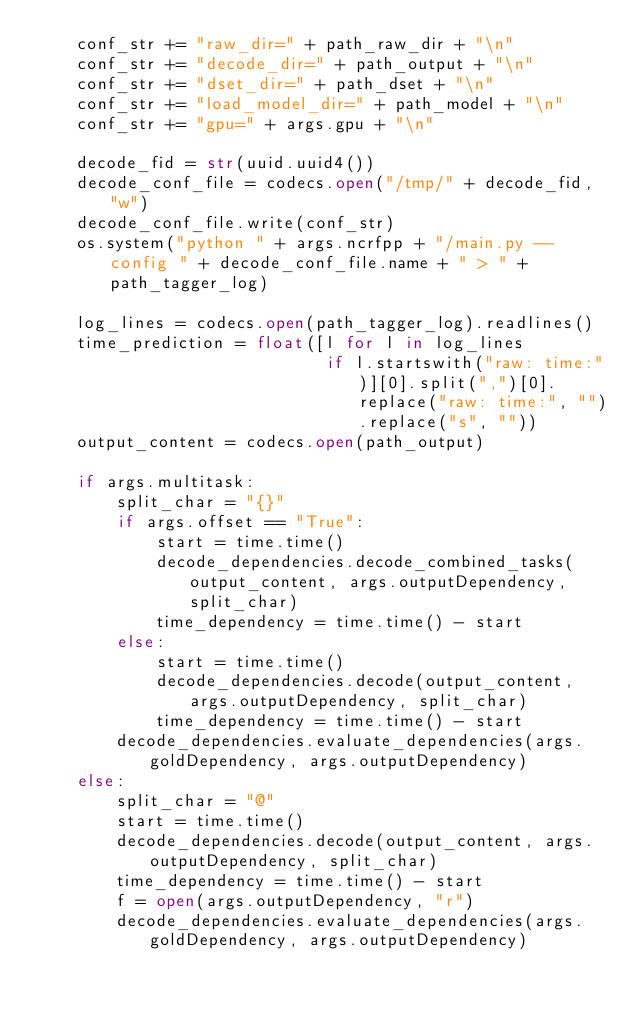Convert code to text. <code><loc_0><loc_0><loc_500><loc_500><_Python_>    conf_str += "raw_dir=" + path_raw_dir + "\n"
    conf_str += "decode_dir=" + path_output + "\n"
    conf_str += "dset_dir=" + path_dset + "\n"
    conf_str += "load_model_dir=" + path_model + "\n"
    conf_str += "gpu=" + args.gpu + "\n"

    decode_fid = str(uuid.uuid4())
    decode_conf_file = codecs.open("/tmp/" + decode_fid, "w")
    decode_conf_file.write(conf_str)
    os.system("python " + args.ncrfpp + "/main.py --config " + decode_conf_file.name + " > " + path_tagger_log)

    log_lines = codecs.open(path_tagger_log).readlines()
    time_prediction = float([l for l in log_lines
                             if l.startswith("raw: time:")][0].split(",")[0].replace("raw: time:", "").replace("s", ""))
    output_content = codecs.open(path_output)

    if args.multitask:
        split_char = "{}"
        if args.offset == "True":
            start = time.time()
            decode_dependencies.decode_combined_tasks(output_content, args.outputDependency, split_char)
            time_dependency = time.time() - start
        else:
            start = time.time()
            decode_dependencies.decode(output_content, args.outputDependency, split_char)
            time_dependency = time.time() - start
        decode_dependencies.evaluate_dependencies(args.goldDependency, args.outputDependency)
    else:
        split_char = "@"
        start = time.time()
        decode_dependencies.decode(output_content, args.outputDependency, split_char)
        time_dependency = time.time() - start
        f = open(args.outputDependency, "r")
        decode_dependencies.evaluate_dependencies(args.goldDependency, args.outputDependency)
</code> 